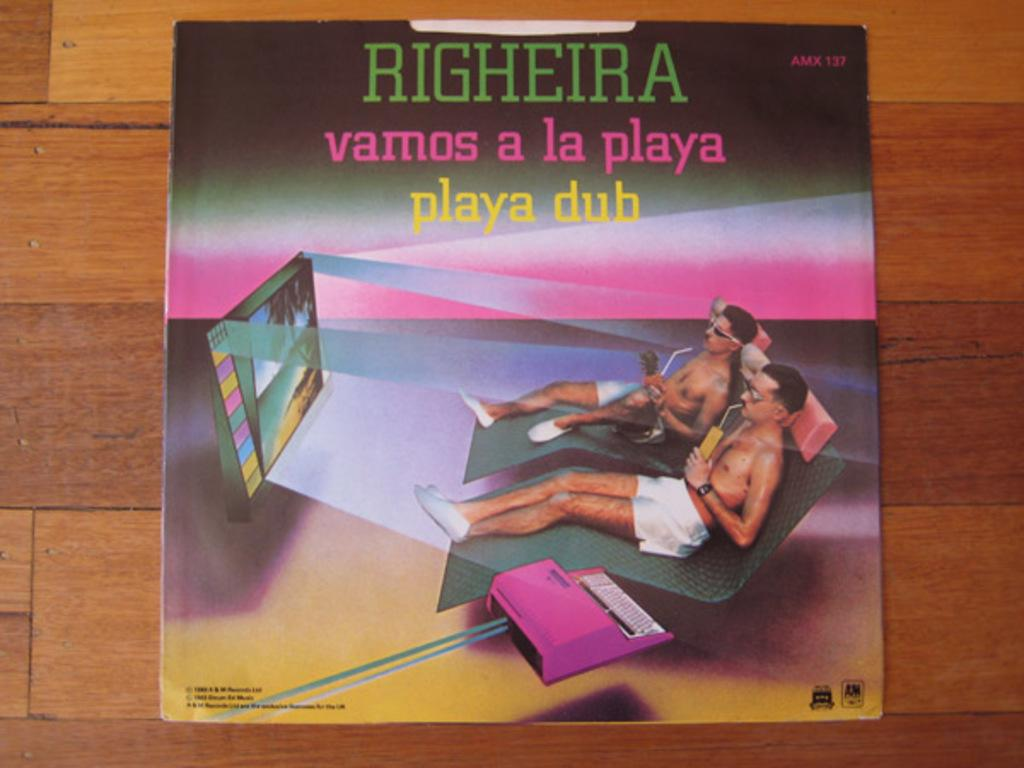What is featured on the poster in the image? The poster contains words and symbols. How many people are sitting in the image? There are two persons sitting on chairs in the image. What electronic device is present in the image? There is a television in the image. What is the poster mounted on? The poster is on a wooden board. What type of produce is being washed with soap in the image? There is no produce or soap present in the image. What kind of cracker is being eaten by the persons in the image? There is no cracker present in the image. 